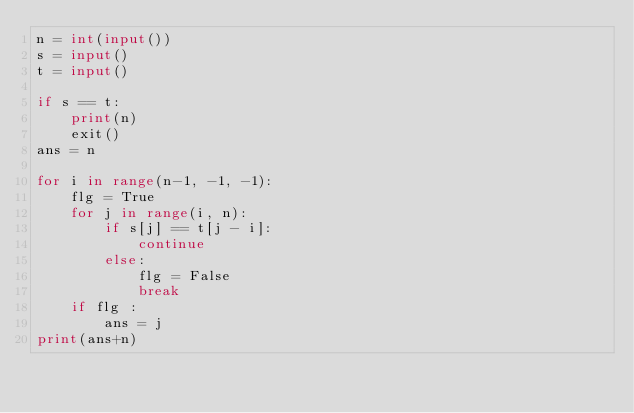Convert code to text. <code><loc_0><loc_0><loc_500><loc_500><_Python_>n = int(input())
s = input()
t = input()

if s == t:
    print(n)
    exit()
ans = n

for i in range(n-1, -1, -1):
    flg = True
    for j in range(i, n):
        if s[j] == t[j - i]:
            continue
        else:
            flg = False
            break
    if flg :
        ans = j
print(ans+n)
</code> 